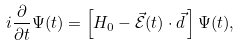Convert formula to latex. <formula><loc_0><loc_0><loc_500><loc_500>i \frac { \partial } { \partial t } \Psi ( t ) = \left [ H _ { 0 } - \vec { \mathcal { E } } ( t ) \cdot \vec { d } \, \right ] \Psi ( t ) ,</formula> 